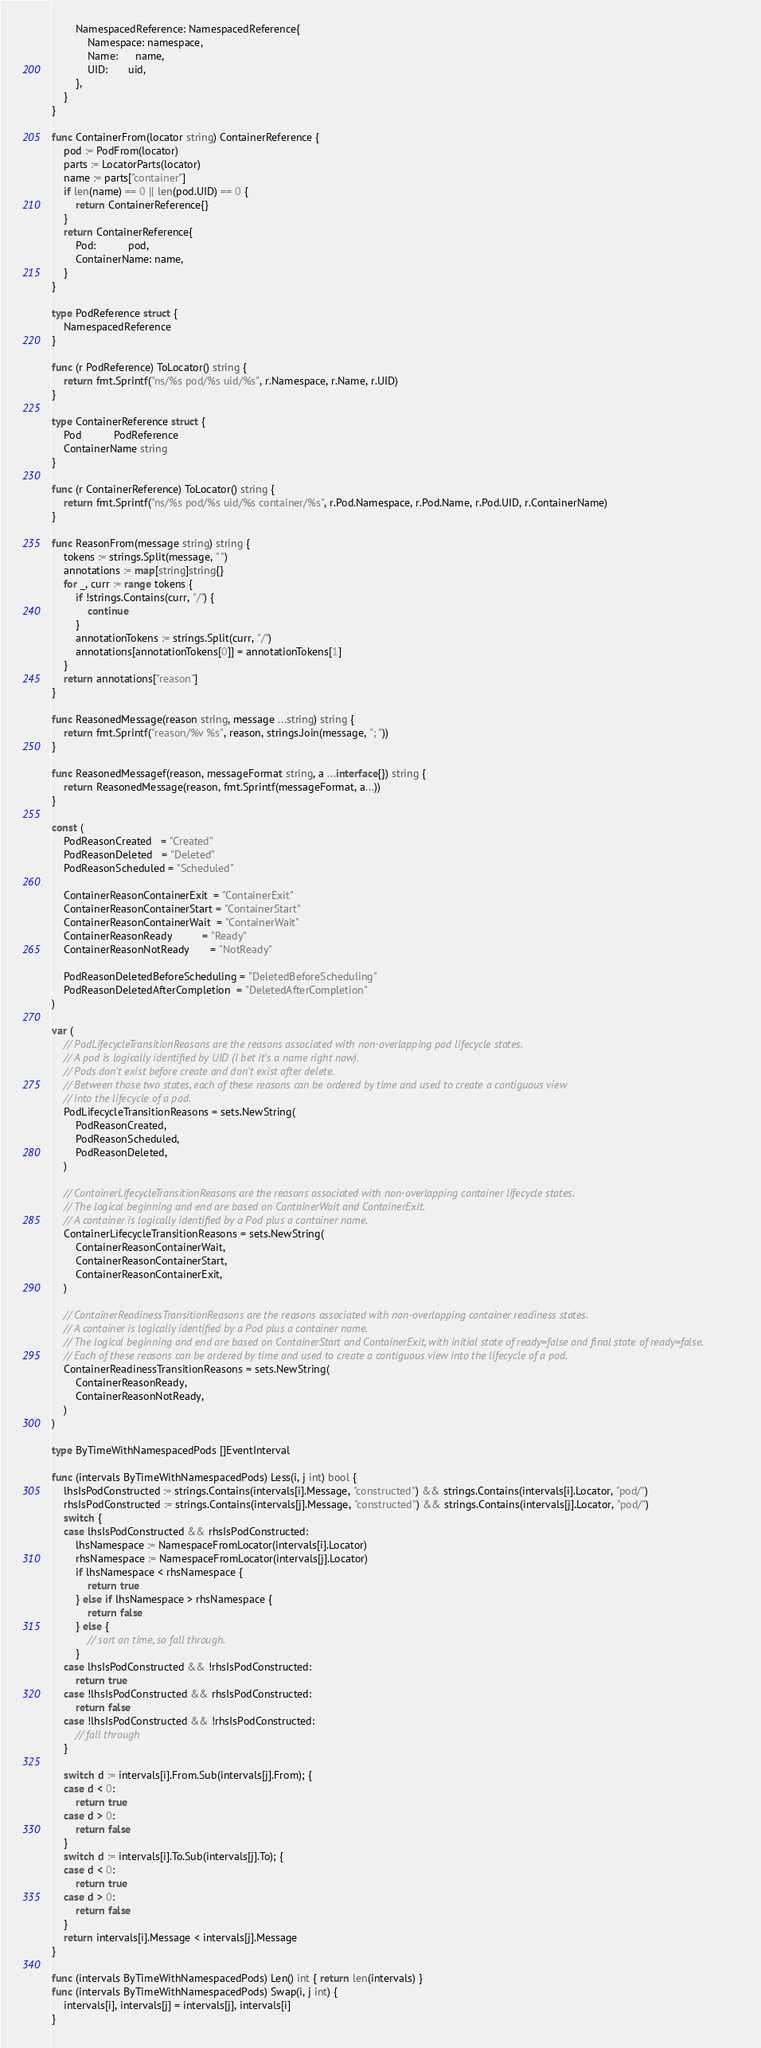<code> <loc_0><loc_0><loc_500><loc_500><_Go_>		NamespacedReference: NamespacedReference{
			Namespace: namespace,
			Name:      name,
			UID:       uid,
		},
	}
}

func ContainerFrom(locator string) ContainerReference {
	pod := PodFrom(locator)
	parts := LocatorParts(locator)
	name := parts["container"]
	if len(name) == 0 || len(pod.UID) == 0 {
		return ContainerReference{}
	}
	return ContainerReference{
		Pod:           pod,
		ContainerName: name,
	}
}

type PodReference struct {
	NamespacedReference
}

func (r PodReference) ToLocator() string {
	return fmt.Sprintf("ns/%s pod/%s uid/%s", r.Namespace, r.Name, r.UID)
}

type ContainerReference struct {
	Pod           PodReference
	ContainerName string
}

func (r ContainerReference) ToLocator() string {
	return fmt.Sprintf("ns/%s pod/%s uid/%s container/%s", r.Pod.Namespace, r.Pod.Name, r.Pod.UID, r.ContainerName)
}

func ReasonFrom(message string) string {
	tokens := strings.Split(message, " ")
	annotations := map[string]string{}
	for _, curr := range tokens {
		if !strings.Contains(curr, "/") {
			continue
		}
		annotationTokens := strings.Split(curr, "/")
		annotations[annotationTokens[0]] = annotationTokens[1]
	}
	return annotations["reason"]
}

func ReasonedMessage(reason string, message ...string) string {
	return fmt.Sprintf("reason/%v %s", reason, strings.Join(message, "; "))
}

func ReasonedMessagef(reason, messageFormat string, a ...interface{}) string {
	return ReasonedMessage(reason, fmt.Sprintf(messageFormat, a...))
}

const (
	PodReasonCreated   = "Created"
	PodReasonDeleted   = "Deleted"
	PodReasonScheduled = "Scheduled"

	ContainerReasonContainerExit  = "ContainerExit"
	ContainerReasonContainerStart = "ContainerStart"
	ContainerReasonContainerWait  = "ContainerWait"
	ContainerReasonReady          = "Ready"
	ContainerReasonNotReady       = "NotReady"

	PodReasonDeletedBeforeScheduling = "DeletedBeforeScheduling"
	PodReasonDeletedAfterCompletion  = "DeletedAfterCompletion"
)

var (
	// PodLifecycleTransitionReasons are the reasons associated with non-overlapping pod lifecycle states.
	// A pod is logically identified by UID (I bet it's a name right now).
	// Pods don't exist before create and don't exist after delete.
	// Between those two states, each of these reasons can be ordered by time and used to create a contiguous view
	// into the lifecycle of a pod.
	PodLifecycleTransitionReasons = sets.NewString(
		PodReasonCreated,
		PodReasonScheduled,
		PodReasonDeleted,
	)

	// ContainerLifecycleTransitionReasons are the reasons associated with non-overlapping container lifecycle states.
	// The logical beginning and end are based on ContainerWait and ContainerExit.
	// A container is logically identified by a Pod plus a container name.
	ContainerLifecycleTransitionReasons = sets.NewString(
		ContainerReasonContainerWait,
		ContainerReasonContainerStart,
		ContainerReasonContainerExit,
	)

	// ContainerReadinessTransitionReasons are the reasons associated with non-overlapping container readiness states.
	// A container is logically identified by a Pod plus a container name.
	// The logical beginning and end are based on ContainerStart and ContainerExit, with initial state of ready=false and final state of ready=false.
	// Each of these reasons can be ordered by time and used to create a contiguous view into the lifecycle of a pod.
	ContainerReadinessTransitionReasons = sets.NewString(
		ContainerReasonReady,
		ContainerReasonNotReady,
	)
)

type ByTimeWithNamespacedPods []EventInterval

func (intervals ByTimeWithNamespacedPods) Less(i, j int) bool {
	lhsIsPodConstructed := strings.Contains(intervals[i].Message, "constructed") && strings.Contains(intervals[i].Locator, "pod/")
	rhsIsPodConstructed := strings.Contains(intervals[j].Message, "constructed") && strings.Contains(intervals[j].Locator, "pod/")
	switch {
	case lhsIsPodConstructed && rhsIsPodConstructed:
		lhsNamespace := NamespaceFromLocator(intervals[i].Locator)
		rhsNamespace := NamespaceFromLocator(intervals[j].Locator)
		if lhsNamespace < rhsNamespace {
			return true
		} else if lhsNamespace > rhsNamespace {
			return false
		} else {
			// sort on time, so fall through.
		}
	case lhsIsPodConstructed && !rhsIsPodConstructed:
		return true
	case !lhsIsPodConstructed && rhsIsPodConstructed:
		return false
	case !lhsIsPodConstructed && !rhsIsPodConstructed:
		// fall through
	}

	switch d := intervals[i].From.Sub(intervals[j].From); {
	case d < 0:
		return true
	case d > 0:
		return false
	}
	switch d := intervals[i].To.Sub(intervals[j].To); {
	case d < 0:
		return true
	case d > 0:
		return false
	}
	return intervals[i].Message < intervals[j].Message
}

func (intervals ByTimeWithNamespacedPods) Len() int { return len(intervals) }
func (intervals ByTimeWithNamespacedPods) Swap(i, j int) {
	intervals[i], intervals[j] = intervals[j], intervals[i]
}
</code> 